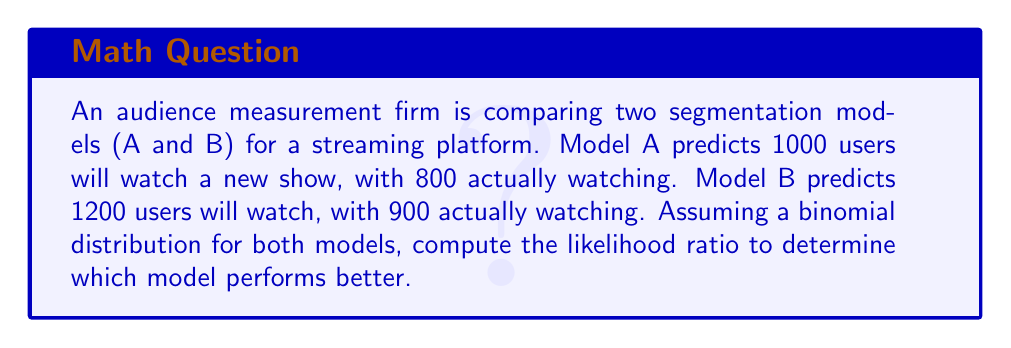Can you solve this math problem? To compute the likelihood ratio, we need to follow these steps:

1) First, calculate the likelihood for each model using the binomial probability mass function:

   $P(X=k|n,p) = \binom{n}{k} p^k (1-p)^{n-k}$

   where $n$ is the predicted number of viewers, $k$ is the actual number of viewers, and $p$ is the probability of success (assumed to be 0.5 for both models).

2) For Model A:
   $L_A = \binom{1000}{800} (0.5)^{800} (0.5)^{200}$

3) For Model B:
   $L_B = \binom{1200}{900} (0.5)^{900} (0.5)^{300}$

4) The likelihood ratio is then calculated as:

   $LR = \frac{L_A}{L_B}$

5) Simplify:
   $$LR = \frac{\binom{1000}{800} (0.5)^{1000}}{\binom{1200}{900} (0.5)^{1200}}$$

6) Calculate the binomial coefficients:
   $\binom{1000}{800} = 2.7028 \times 10^{232}$
   $\binom{1200}{900} = 1.3669 \times 10^{278}$

7) Substitute and calculate:
   $$LR = \frac{2.7028 \times 10^{232} \times (0.5)^{1000}}{1.3669 \times 10^{278} \times (0.5)^{1200}}$$
   $$LR = \frac{2.7028 \times 10^{232}}{1.3669 \times 10^{278}} \times (0.5)^{-200}$$
   $$LR \approx 1.4142 \times 10^{-46}$$

8) Since LR < 1, Model B performs better than Model A.
Answer: $1.4142 \times 10^{-46}$; Model B performs better 